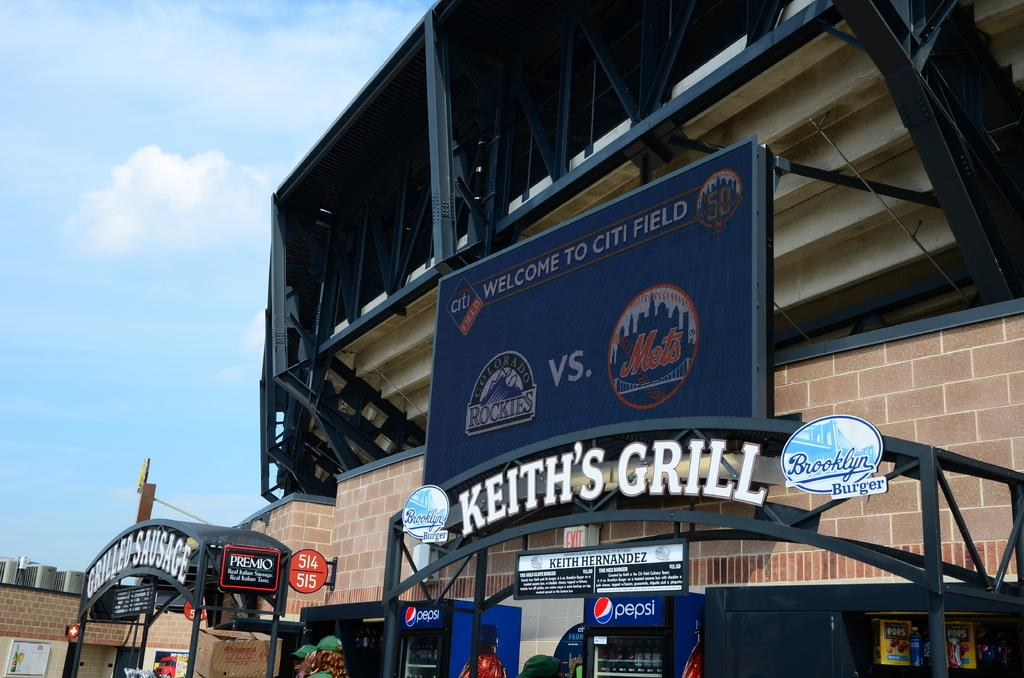What type of structures can be seen in the image? There are buildings in the image. What other objects are present in the image? There are boards, poles, fridges, and some objects visible in the image. Can you describe the text visible in the image? There is text visible in the image, but its content is not specified. Are there any people in the image? Yes, there are people in the image. What is visible at the top of the image? The sky is visible at the top of the image. How many trucks are present in the image? There is no mention of trucks in the image; the facts provided only mention buildings, boards, poles, fridges, people, and objects. What type of disease is being treated in the image? There is no mention of any disease or medical treatment in the image; the facts provided focus on the presence of buildings, boards, poles, fridges, people, and objects. 